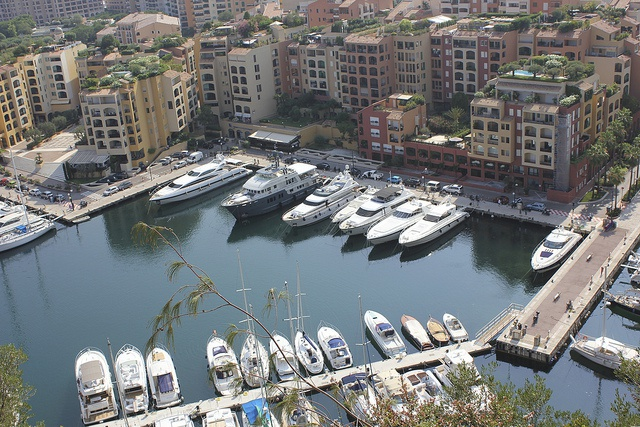Describe the objects in this image and their specific colors. I can see boat in gray, white, and darkgray tones, boat in gray, darkgray, black, and lightgray tones, boat in gray, darkgray, lightgray, and black tones, boat in gray, white, darkgray, and black tones, and car in gray, black, and darkgray tones in this image. 